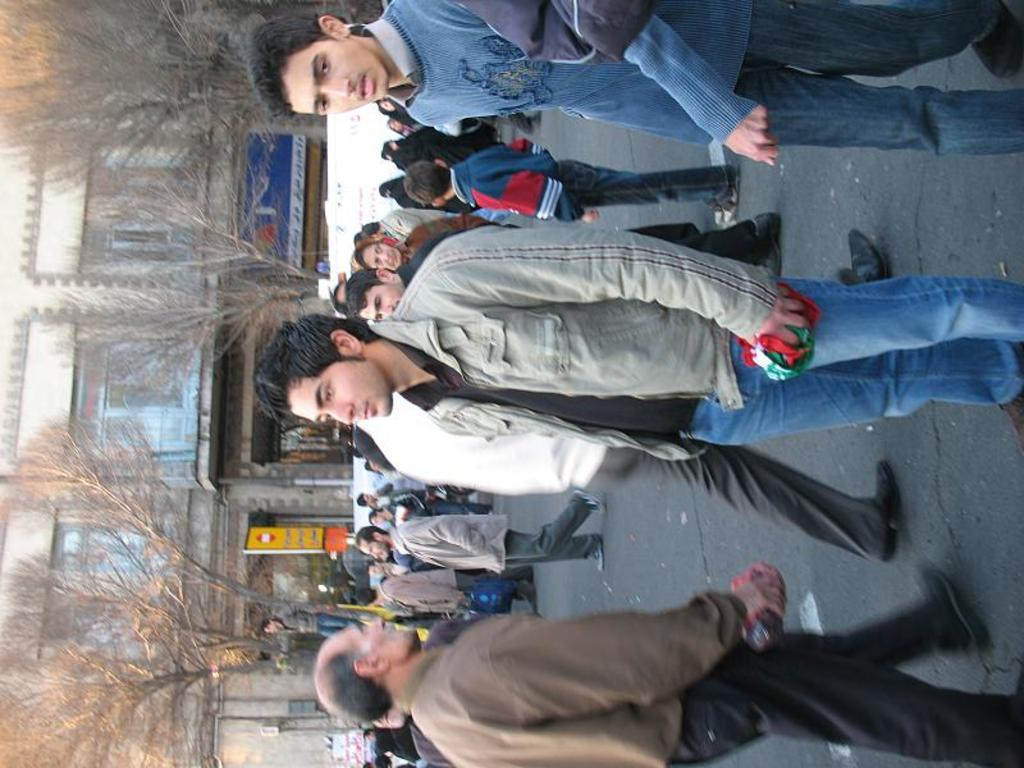How many people are in the image? There is a group of people in the image. What are the people in the image doing? Some people are standing, while others are walking. What can be seen in the background of the image? There are trees, hoardings, and buildings in the background of the image. What type of drink is being consumed by the person in the wilderness in the image? There is no person in the wilderness in the image, nor is there any drink being consumed. 